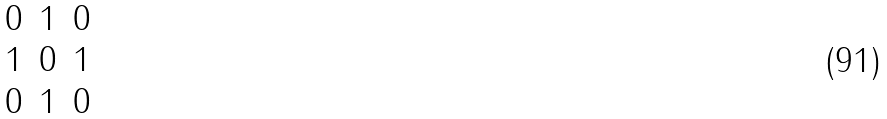<formula> <loc_0><loc_0><loc_500><loc_500>\begin{matrix} 0 & 1 & 0 \\ 1 & 0 & 1 \\ 0 & 1 & 0 \end{matrix}</formula> 